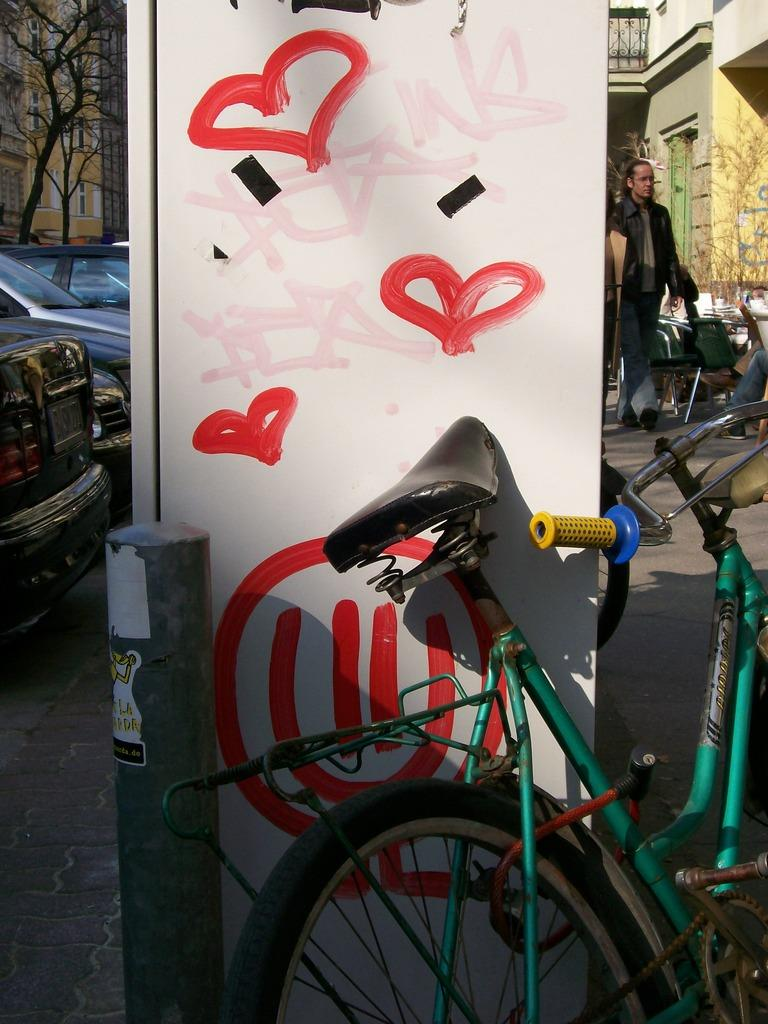What is on the pole in the image? There is a poster on a pole in the image. What mode of transportation can be seen in the image? There is a bicycle in the image. What type of surface is present in the image? There is a board in the image. What are the vehicles in the image? There are vehicles in the image. What type of furniture is in the image? There are chairs in the image. What type of natural element is present in the image? There are trees in the image. What is present in the image that can be used to describe objects in general? There are objects in the image. What type of structures can be seen in the background of the image? There are buildings in the background of the image. Where is the volcano located in the image? There is no volcano present in the image. What type of kitchen appliance is on the table in the image? There is no kettle or table present in the image. 